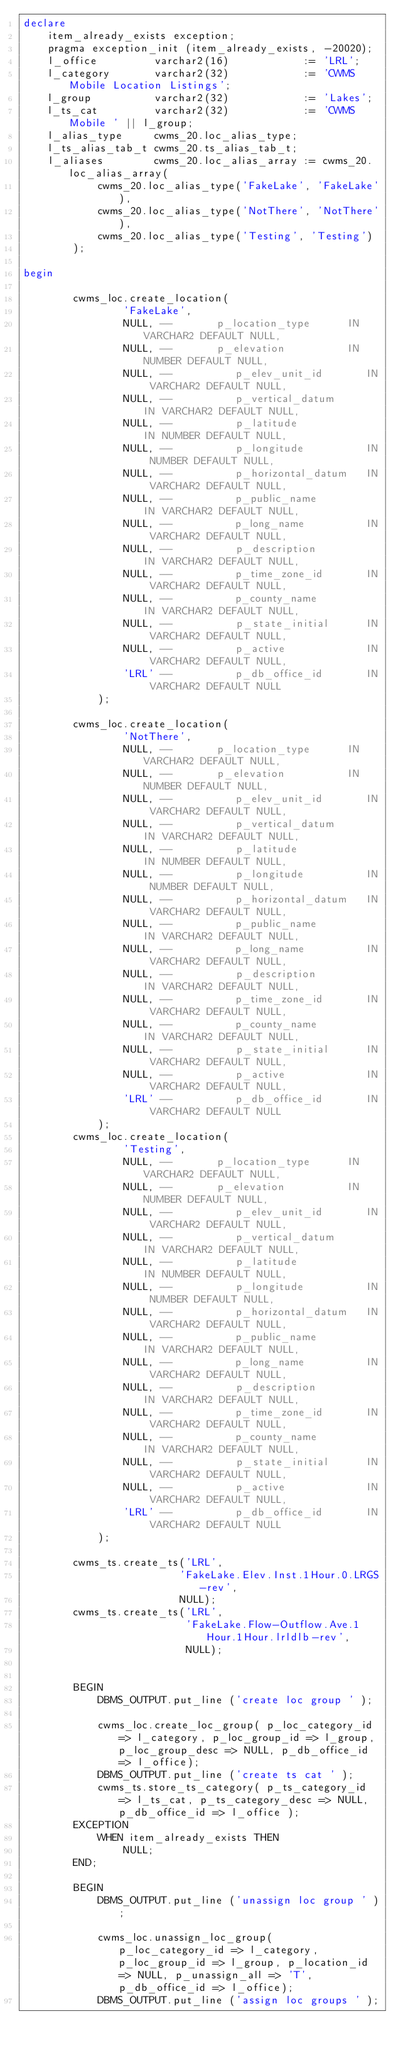<code> <loc_0><loc_0><loc_500><loc_500><_SQL_>declare
    item_already_exists exception;
    pragma exception_init (item_already_exists, -20020);
    l_office         varchar2(16)            := 'LRL';
    l_category       varchar2(32)            := 'CWMS Mobile Location Listings';
    l_group          varchar2(32)            := 'Lakes';
    l_ts_cat         varchar2(32)            := 'CWMS Mobile ' || l_group;
    l_alias_type     cwms_20.loc_alias_type;
    l_ts_alias_tab_t cwms_20.ts_alias_tab_t;
    l_aliases        cwms_20.loc_alias_array := cwms_20.loc_alias_array(
            cwms_20.loc_alias_type('FakeLake', 'FakeLake'),
            cwms_20.loc_alias_type('NotThere', 'NotThere'),
            cwms_20.loc_alias_type('Testing', 'Testing')
        );

begin

        cwms_loc.create_location(
                'FakeLake',
                NULL, --       p_location_type      IN VARCHAR2 DEFAULT NULL,
                NULL, --       p_elevation          IN NUMBER DEFAULT NULL,
                NULL, --          p_elev_unit_id       IN VARCHAR2 DEFAULT NULL,
                NULL, --          p_vertical_datum      IN VARCHAR2 DEFAULT NULL,
                NULL, --          p_latitude            IN NUMBER DEFAULT NULL,
                NULL, --          p_longitude          IN NUMBER DEFAULT NULL,
                NULL, --          p_horizontal_datum   IN VARCHAR2 DEFAULT NULL,
                NULL, --          p_public_name         IN VARCHAR2 DEFAULT NULL,
                NULL, --          p_long_name          IN VARCHAR2 DEFAULT NULL,
                NULL, --          p_description         IN VARCHAR2 DEFAULT NULL,
                NULL, --          p_time_zone_id       IN VARCHAR2 DEFAULT NULL,
                NULL, --          p_county_name         IN VARCHAR2 DEFAULT NULL,
                NULL, --          p_state_initial      IN VARCHAR2 DEFAULT NULL,
                NULL, --          p_active             IN VARCHAR2 DEFAULT NULL,
                'LRL' --          p_db_office_id       IN VARCHAR2 DEFAULT NULL
            );

        cwms_loc.create_location(
                'NotThere',
                NULL, --       p_location_type      IN VARCHAR2 DEFAULT NULL,
                NULL, --       p_elevation          IN NUMBER DEFAULT NULL,
                NULL, --          p_elev_unit_id       IN VARCHAR2 DEFAULT NULL,
                NULL, --          p_vertical_datum      IN VARCHAR2 DEFAULT NULL,
                NULL, --          p_latitude            IN NUMBER DEFAULT NULL,
                NULL, --          p_longitude          IN NUMBER DEFAULT NULL,
                NULL, --          p_horizontal_datum   IN VARCHAR2 DEFAULT NULL,
                NULL, --          p_public_name         IN VARCHAR2 DEFAULT NULL,
                NULL, --          p_long_name          IN VARCHAR2 DEFAULT NULL,
                NULL, --          p_description         IN VARCHAR2 DEFAULT NULL,
                NULL, --          p_time_zone_id       IN VARCHAR2 DEFAULT NULL,
                NULL, --          p_county_name         IN VARCHAR2 DEFAULT NULL,
                NULL, --          p_state_initial      IN VARCHAR2 DEFAULT NULL,
                NULL, --          p_active             IN VARCHAR2 DEFAULT NULL,
                'LRL' --          p_db_office_id       IN VARCHAR2 DEFAULT NULL
            );
        cwms_loc.create_location(
                'Testing',
                NULL, --       p_location_type      IN VARCHAR2 DEFAULT NULL,
                NULL, --       p_elevation          IN NUMBER DEFAULT NULL,
                NULL, --          p_elev_unit_id       IN VARCHAR2 DEFAULT NULL,
                NULL, --          p_vertical_datum      IN VARCHAR2 DEFAULT NULL,
                NULL, --          p_latitude            IN NUMBER DEFAULT NULL,
                NULL, --          p_longitude          IN NUMBER DEFAULT NULL,
                NULL, --          p_horizontal_datum   IN VARCHAR2 DEFAULT NULL,
                NULL, --          p_public_name         IN VARCHAR2 DEFAULT NULL,
                NULL, --          p_long_name          IN VARCHAR2 DEFAULT NULL,
                NULL, --          p_description         IN VARCHAR2 DEFAULT NULL,
                NULL, --          p_time_zone_id       IN VARCHAR2 DEFAULT NULL,
                NULL, --          p_county_name         IN VARCHAR2 DEFAULT NULL,
                NULL, --          p_state_initial      IN VARCHAR2 DEFAULT NULL,
                NULL, --          p_active             IN VARCHAR2 DEFAULT NULL,
                'LRL' --          p_db_office_id       IN VARCHAR2 DEFAULT NULL
            );

        cwms_ts.create_ts('LRL',
                         'FakeLake.Elev.Inst.1Hour.0.LRGS-rev',
                         NULL);
        cwms_ts.create_ts('LRL',
                          'FakeLake.Flow-Outflow.Ave.1Hour.1Hour.lrldlb-rev',
                          NULL);


        BEGIN
            DBMS_OUTPUT.put_line ('create loc group ' );

            cwms_loc.create_loc_group( p_loc_category_id => l_category, p_loc_group_id => l_group, p_loc_group_desc => NULL, p_db_office_id => l_office);
            DBMS_OUTPUT.put_line ('create ts cat ' );
            cwms_ts.store_ts_category( p_ts_category_id => l_ts_cat, p_ts_category_desc => NULL, p_db_office_id => l_office );
        EXCEPTION
            WHEN item_already_exists THEN
                NULL;
        END;

        BEGIN
            DBMS_OUTPUT.put_line ('unassign loc group ' );

            cwms_loc.unassign_loc_group( p_loc_category_id => l_category, p_loc_group_id => l_group, p_location_id => NULL, p_unassign_all => 'T', p_db_office_id => l_office);
            DBMS_OUTPUT.put_line ('assign loc groups ' );</code> 